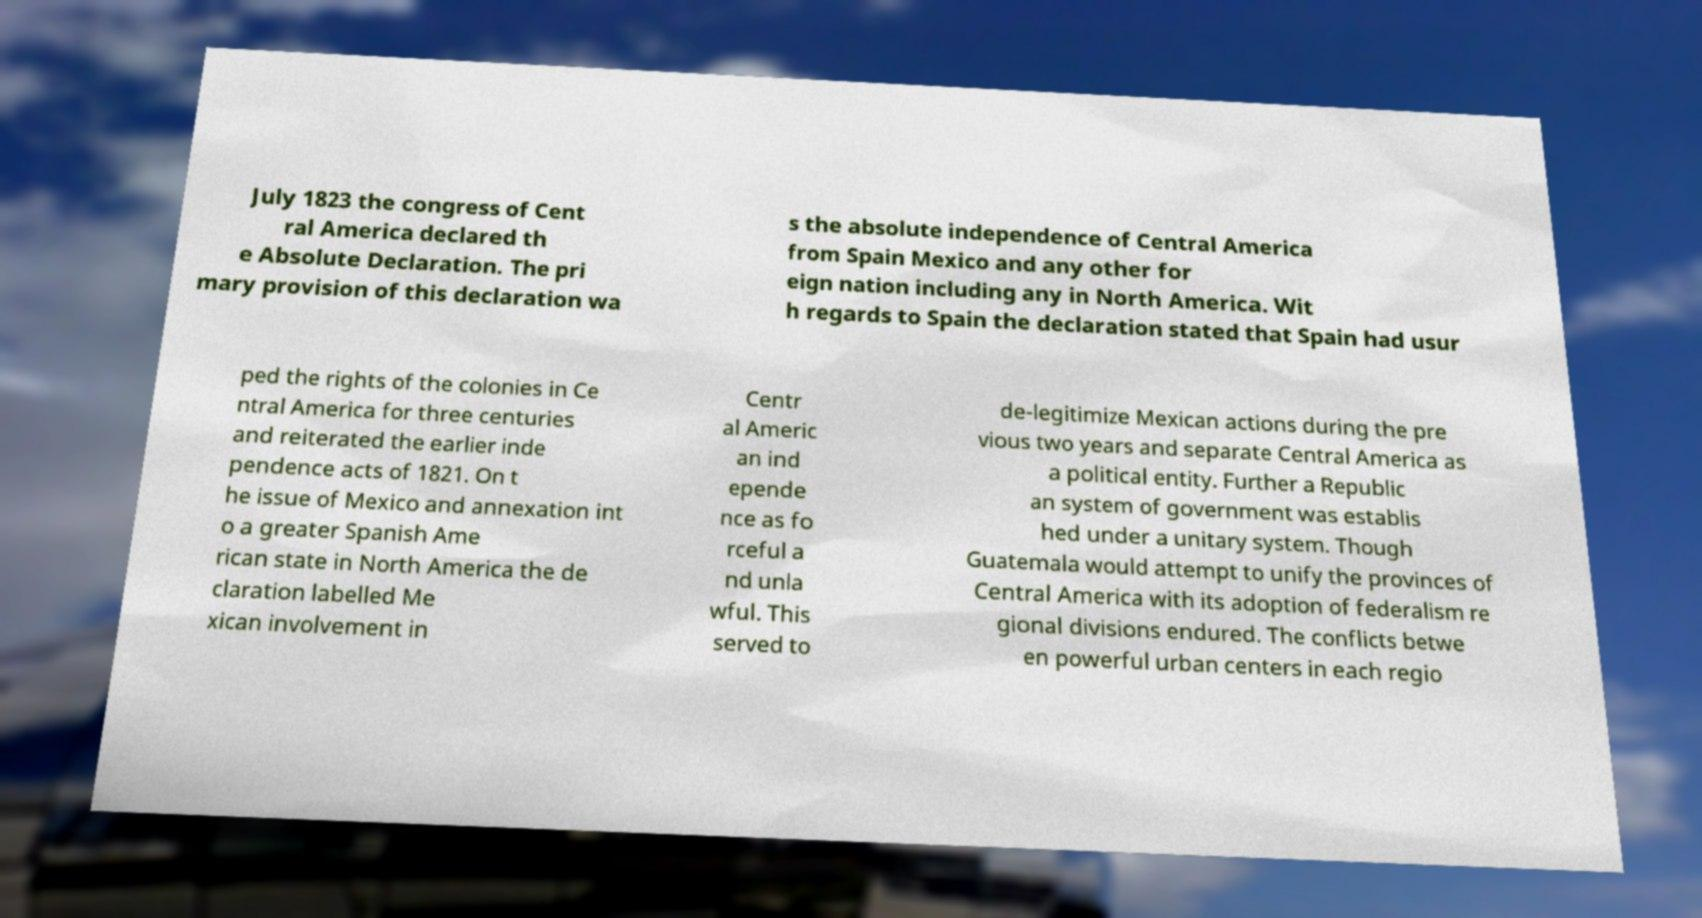Please identify and transcribe the text found in this image. July 1823 the congress of Cent ral America declared th e Absolute Declaration. The pri mary provision of this declaration wa s the absolute independence of Central America from Spain Mexico and any other for eign nation including any in North America. Wit h regards to Spain the declaration stated that Spain had usur ped the rights of the colonies in Ce ntral America for three centuries and reiterated the earlier inde pendence acts of 1821. On t he issue of Mexico and annexation int o a greater Spanish Ame rican state in North America the de claration labelled Me xican involvement in Centr al Americ an ind epende nce as fo rceful a nd unla wful. This served to de-legitimize Mexican actions during the pre vious two years and separate Central America as a political entity. Further a Republic an system of government was establis hed under a unitary system. Though Guatemala would attempt to unify the provinces of Central America with its adoption of federalism re gional divisions endured. The conflicts betwe en powerful urban centers in each regio 